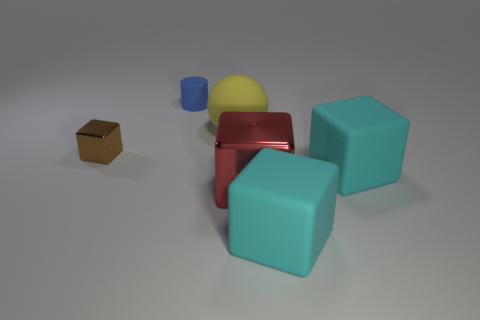What is the size of the metal object that is on the right side of the block that is left of the big red block?
Your response must be concise. Large. How many things are large spheres or blocks that are behind the big red block?
Make the answer very short. 3. There is a metallic thing that is to the left of the yellow rubber thing; is it the same shape as the big yellow matte object?
Your answer should be very brief. No. There is a metal block that is to the right of the tiny brown metallic object on the left side of the tiny matte cylinder; how many big cyan objects are behind it?
Give a very brief answer. 1. Are there any other things that have the same shape as the red object?
Provide a short and direct response. Yes. How many objects are either small red objects or yellow balls?
Provide a succinct answer. 1. Do the big red object and the thing behind the yellow object have the same shape?
Give a very brief answer. No. What shape is the object that is behind the matte ball?
Your response must be concise. Cylinder. Is the tiny brown thing the same shape as the small blue rubber object?
Keep it short and to the point. No. There is a brown object that is the same shape as the red thing; what size is it?
Make the answer very short. Small. 